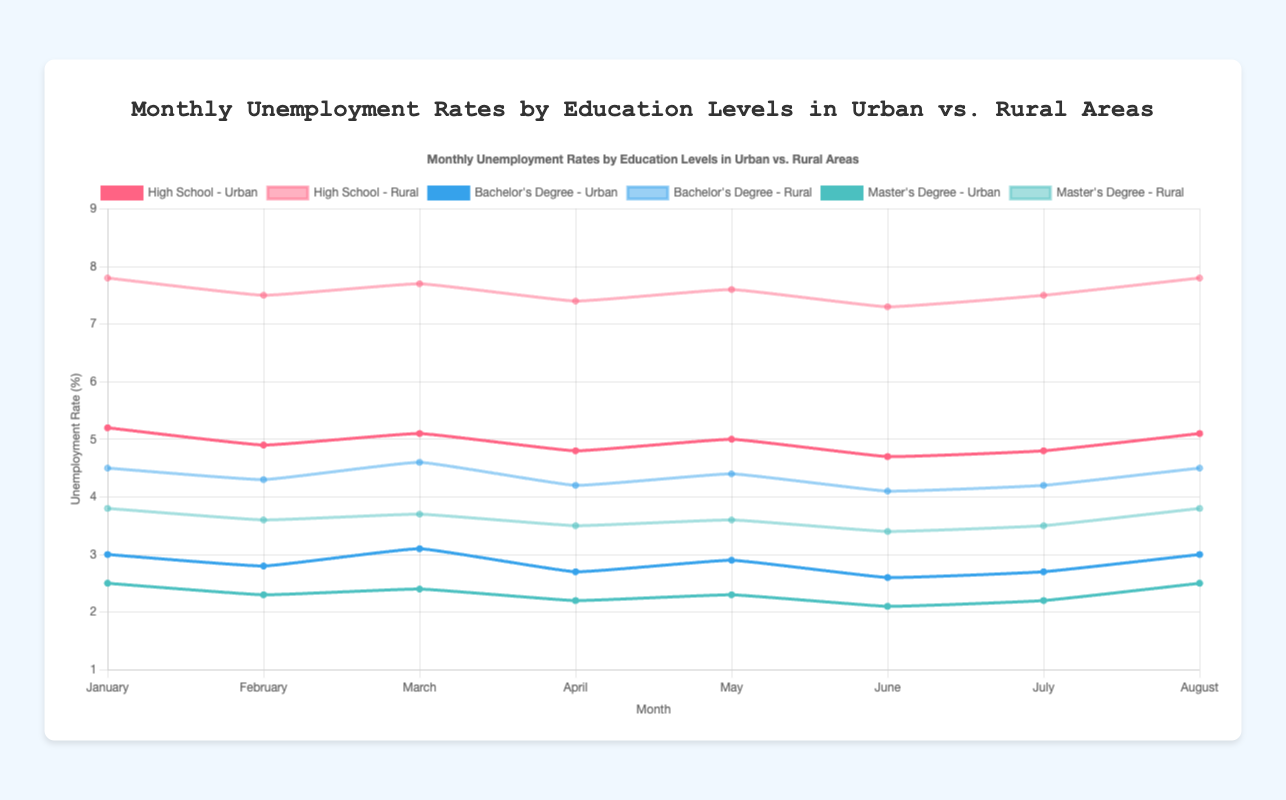What is the unemployment rate for people with a high school education in urban areas in January? Find the data point for high school education and urban areas in January. The rate is 5.2%.
Answer: 5.2% Which education level has the lowest unemployment rate in rural areas in March? Compare the unemployment rates for each education level in rural areas in March: High School (7.7%), Bachelor's Degree (4.6%), Master's Degree (3.7%). Master's Degree has the lowest rate.
Answer: Master's Degree By how much does the unemployment rate for people with a Bachelor's Degree in urban areas decrease from January to February? Subtract the unemployment rate in February (2.8%) from the rate in January (3.0%). The difference is 3.0% - 2.8% = 0.2%.
Answer: 0.2% How does the unemployment rate for people with a Master's Degree in rural areas in June compare to their rate in urban areas? Find the data points for Master's Degree in June for both areas. Rural is 3.4% and urban is 2.1%. Rural is higher than urban.
Answer: Rural > Urban Which line on the chart corresponds to the Urban unemployment rate for people with a High School education? The line is the one colored in red and has data points at 5.2%, 4.9%, 5.1%, 4.8%, 5.0%, 4.7%, 4.8%, and 5.1% across various months.
Answer: Red line What is the average unemployment rate in rural areas for people with a Bachelor's Degree from January to August? Sum the unemployment rates: 4.5% (Jan) + 4.3% (Feb) + 4.6% (Mar) + 4.2% (Apr) + 4.4% (May) + 4.1% (Jun) + 4.2% (Jul) + 4.5% (Aug). The total is 34.8. Divide by 8 months: 34.8 / 8 = 4.35%.
Answer: 4.35% By how much did the unemployment rate change in rural areas for people with a Master's Degree from May to June? Subtract the unemployment rate in June (3.4%) from the rate in May (3.6%). The difference is 3.6% - 3.4% = 0.2%.
Answer: 0.2% Which month shows the highest unemployment rate for people with a Master's Degree in urban areas? Compare the data points for each month for Master's Degree in urban areas: January (2.5%), February (2.3%), March (2.4%), April (2.2%), May (2.3%), June (2.1%), July (2.2%), August (2.5%). January and August, both months have the highest rate of 2.5%.
Answer: January and August What is the total change in unemployment rate for people with a High School education in rural areas from January to July? Subtract the rate in July (7.5%) from January (7.8%). The total change is 7.8% - 7.5% = 0.3%.
Answer: 0.3% Which education level consistently has the lowest unemployment rate in urban areas? Compare the data for each education level across all months. The Master's Degree consistently has the lowest rate.
Answer: Master's Degree 